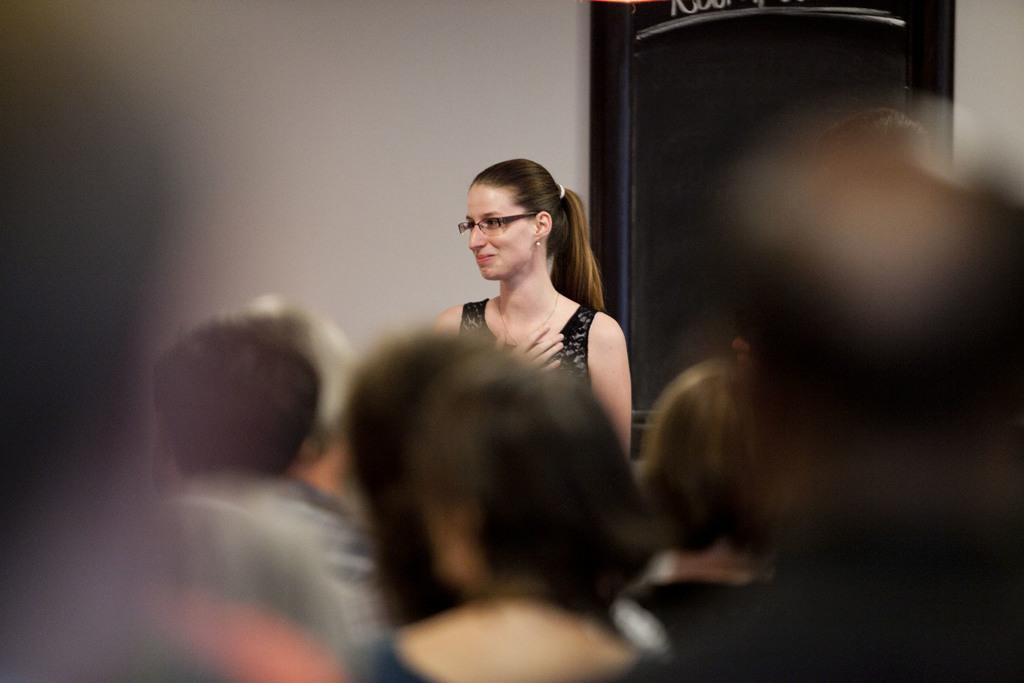Can you describe this image briefly? In this picture I can see a woman standing, in front I can see few people. 